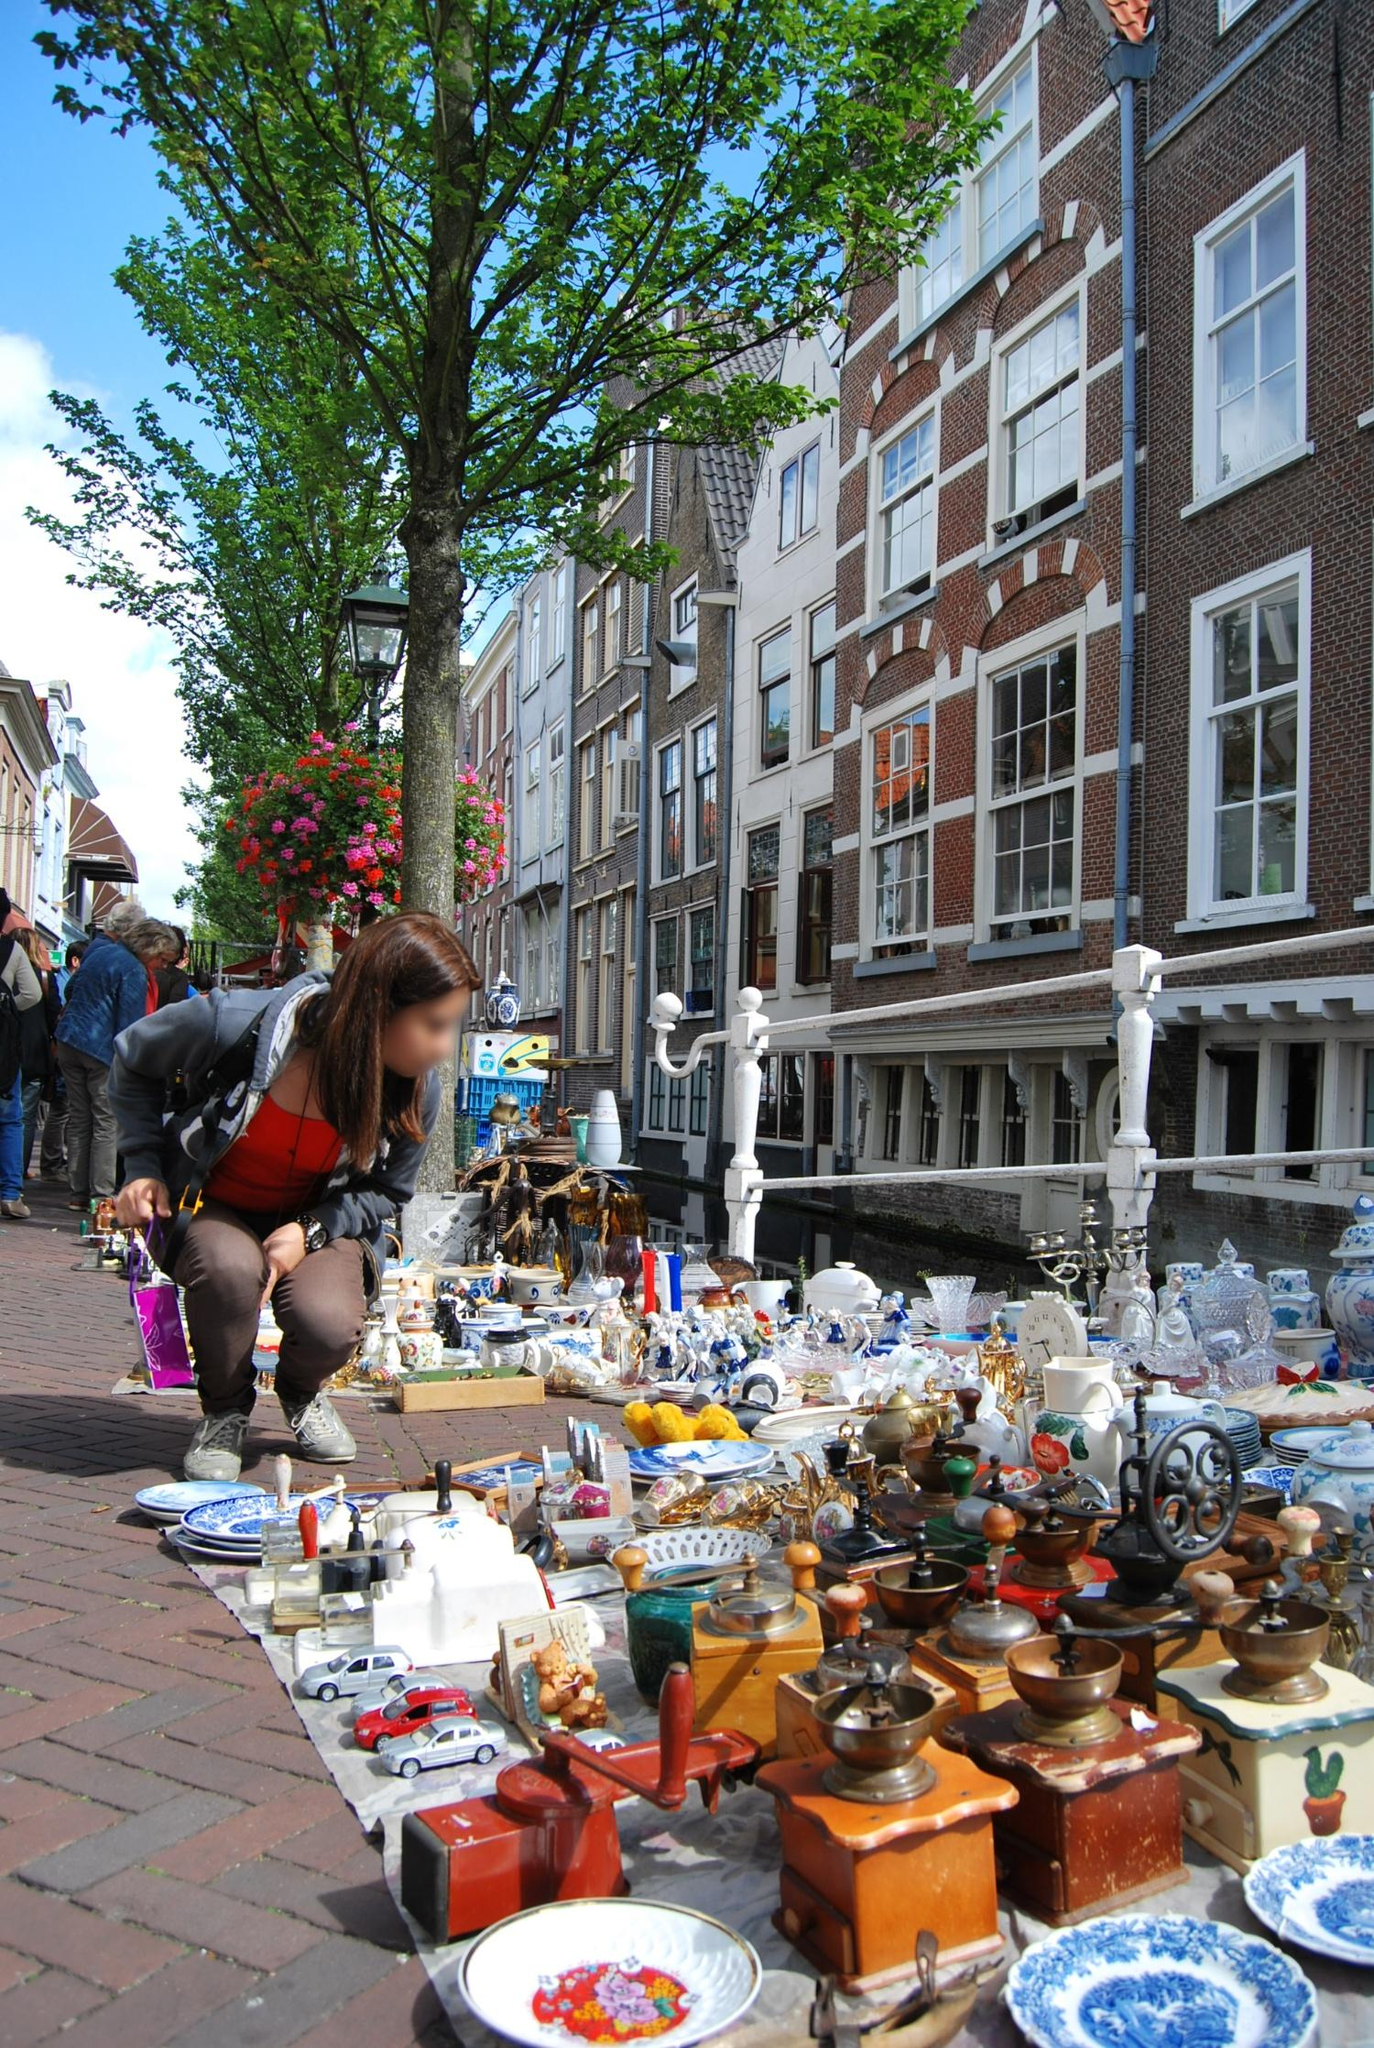What can you tell me about the historical significance of the buildings seen in the background? The buildings in the background exhibit the classic architectural style of Amsterdam, known for its narrow, tall facades constructed predominantly from brick. This style dates back to the Dutch Golden Age in the 17th century when the city experienced a significant economic boom. During this time, Amsterdam's wealthy merchants built imposing homes and warehouses along its canals. The large, multi-paned windows were designed to maximize natural light in the often overcast city.

These buildings are not just architectural marvels but also historical landmarks. Many have been preserved meticulously to reflect their original grandeur, showcasing the rich history and culture of Amsterdam. The intricate gables, unique to Dutch architecture, and ornate details symbolize the era's craftsmanship and prosperity. 